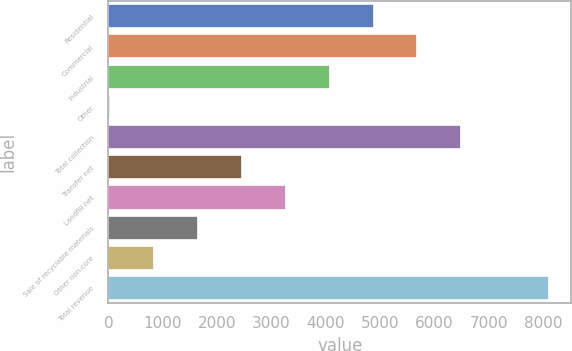Convert chart to OTSL. <chart><loc_0><loc_0><loc_500><loc_500><bar_chart><fcel>Residential<fcel>Commercial<fcel>Industrial<fcel>Other<fcel>Total collection<fcel>Transfer net<fcel>Landfill net<fcel>Sale of recyclable materials<fcel>Other non-core<fcel>Total revenue<nl><fcel>4875.8<fcel>5683.5<fcel>4068.1<fcel>29.6<fcel>6491.2<fcel>2452.7<fcel>3260.4<fcel>1645<fcel>837.3<fcel>8106.6<nl></chart> 